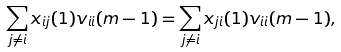Convert formula to latex. <formula><loc_0><loc_0><loc_500><loc_500>\sum _ { j \ne i } x _ { i j } ( 1 ) v _ { i i } ( m - 1 ) = \sum _ { j \ne i } x _ { j i } ( 1 ) v _ { i i } ( m - 1 ) ,</formula> 